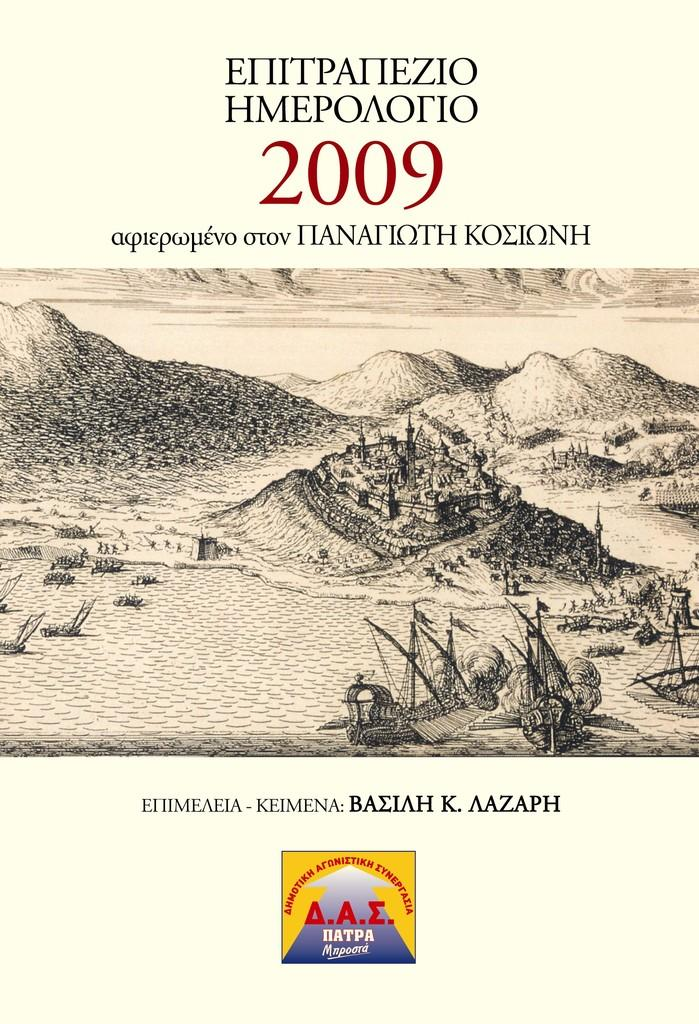<image>
Present a compact description of the photo's key features. mountains and landscape with a castle taken in 2009. 